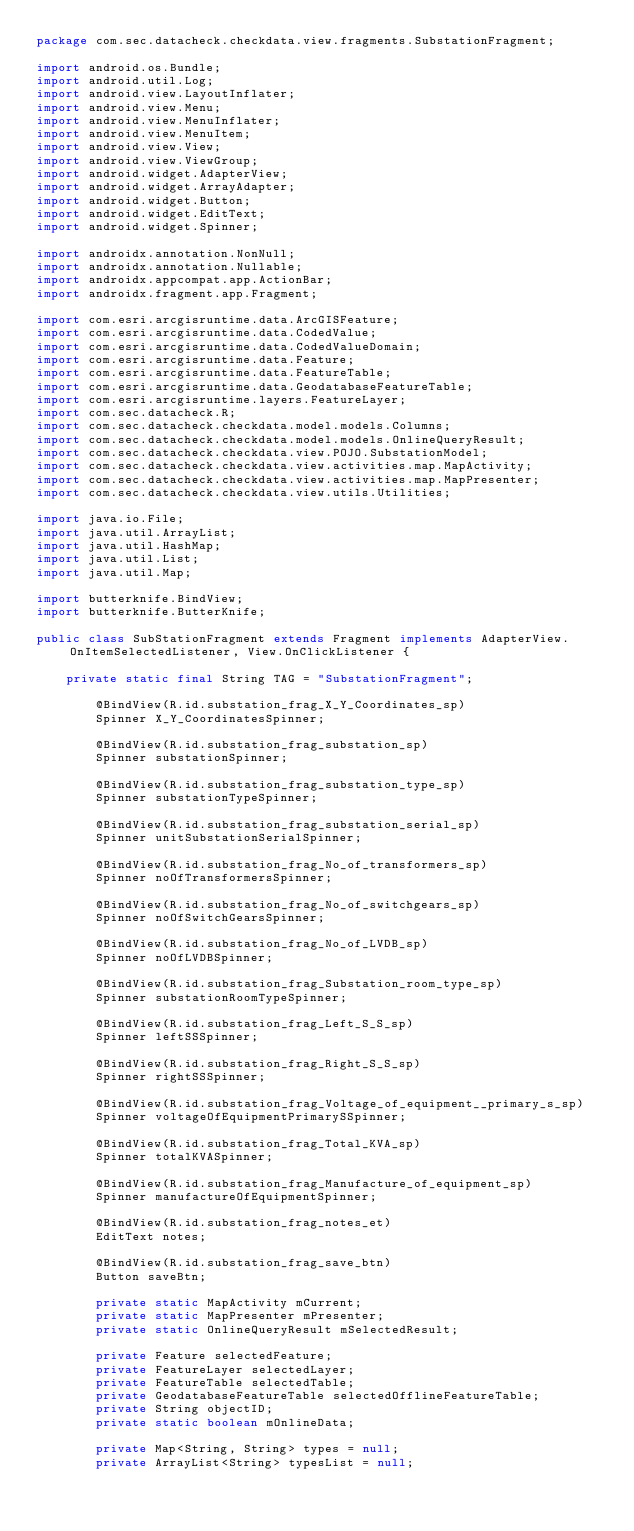<code> <loc_0><loc_0><loc_500><loc_500><_Java_>package com.sec.datacheck.checkdata.view.fragments.SubstationFragment;

import android.os.Bundle;
import android.util.Log;
import android.view.LayoutInflater;
import android.view.Menu;
import android.view.MenuInflater;
import android.view.MenuItem;
import android.view.View;
import android.view.ViewGroup;
import android.widget.AdapterView;
import android.widget.ArrayAdapter;
import android.widget.Button;
import android.widget.EditText;
import android.widget.Spinner;

import androidx.annotation.NonNull;
import androidx.annotation.Nullable;
import androidx.appcompat.app.ActionBar;
import androidx.fragment.app.Fragment;

import com.esri.arcgisruntime.data.ArcGISFeature;
import com.esri.arcgisruntime.data.CodedValue;
import com.esri.arcgisruntime.data.CodedValueDomain;
import com.esri.arcgisruntime.data.Feature;
import com.esri.arcgisruntime.data.FeatureTable;
import com.esri.arcgisruntime.data.GeodatabaseFeatureTable;
import com.esri.arcgisruntime.layers.FeatureLayer;
import com.sec.datacheck.R;
import com.sec.datacheck.checkdata.model.models.Columns;
import com.sec.datacheck.checkdata.model.models.OnlineQueryResult;
import com.sec.datacheck.checkdata.view.POJO.SubstationModel;
import com.sec.datacheck.checkdata.view.activities.map.MapActivity;
import com.sec.datacheck.checkdata.view.activities.map.MapPresenter;
import com.sec.datacheck.checkdata.view.utils.Utilities;

import java.io.File;
import java.util.ArrayList;
import java.util.HashMap;
import java.util.List;
import java.util.Map;

import butterknife.BindView;
import butterknife.ButterKnife;

public class SubStationFragment extends Fragment implements AdapterView.OnItemSelectedListener, View.OnClickListener {

    private static final String TAG = "SubstationFragment";

        @BindView(R.id.substation_frag_X_Y_Coordinates_sp)
        Spinner X_Y_CoordinatesSpinner;

        @BindView(R.id.substation_frag_substation_sp)
        Spinner substationSpinner;

        @BindView(R.id.substation_frag_substation_type_sp)
        Spinner substationTypeSpinner;

        @BindView(R.id.substation_frag_substation_serial_sp)
        Spinner unitSubstationSerialSpinner;

        @BindView(R.id.substation_frag_No_of_transformers_sp)
        Spinner noOfTransformersSpinner;

        @BindView(R.id.substation_frag_No_of_switchgears_sp)
        Spinner noOfSwitchGearsSpinner;

        @BindView(R.id.substation_frag_No_of_LVDB_sp)
        Spinner noOfLVDBSpinner;

        @BindView(R.id.substation_frag_Substation_room_type_sp)
        Spinner substationRoomTypeSpinner;

        @BindView(R.id.substation_frag_Left_S_S_sp)
        Spinner leftSSSpinner;

        @BindView(R.id.substation_frag_Right_S_S_sp)
        Spinner rightSSSpinner;

        @BindView(R.id.substation_frag_Voltage_of_equipment__primary_s_sp)
        Spinner voltageOfEquipmentPrimarySSpinner;

        @BindView(R.id.substation_frag_Total_KVA_sp)
        Spinner totalKVASpinner;

        @BindView(R.id.substation_frag_Manufacture_of_equipment_sp)
        Spinner manufactureOfEquipmentSpinner;

        @BindView(R.id.substation_frag_notes_et)
        EditText notes;

        @BindView(R.id.substation_frag_save_btn)
        Button saveBtn;

        private static MapActivity mCurrent;
        private static MapPresenter mPresenter;
        private static OnlineQueryResult mSelectedResult;

        private Feature selectedFeature;
        private FeatureLayer selectedLayer;
        private FeatureTable selectedTable;
        private GeodatabaseFeatureTable selectedOfflineFeatureTable;
        private String objectID;
        private static boolean mOnlineData;

        private Map<String, String> types = null;
        private ArrayList<String> typesList = null;</code> 